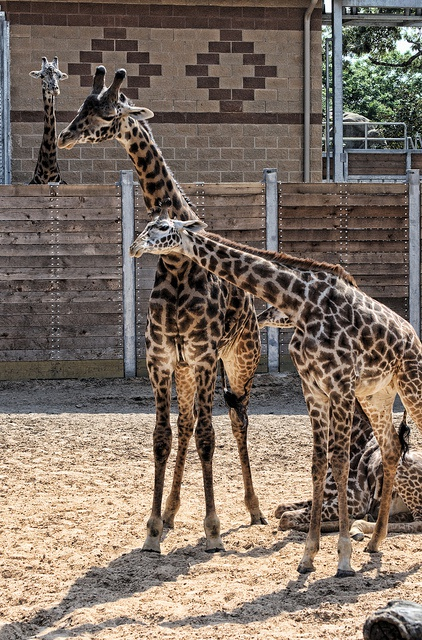Describe the objects in this image and their specific colors. I can see giraffe in gray, black, and darkgray tones, giraffe in gray, black, and maroon tones, giraffe in gray and black tones, and giraffe in gray, black, and darkgray tones in this image. 